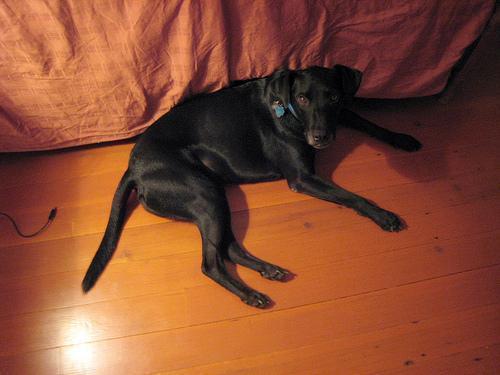How many animals are in the picture?
Give a very brief answer. 1. 